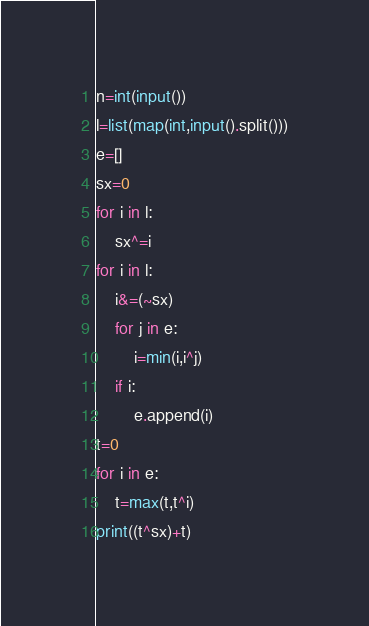Convert code to text. <code><loc_0><loc_0><loc_500><loc_500><_Python_>n=int(input())
l=list(map(int,input().split()))
e=[]
sx=0
for i in l:
    sx^=i
for i in l:
    i&=(~sx)
    for j in e:
        i=min(i,i^j)
    if i:
        e.append(i)
t=0
for i in e:
    t=max(t,t^i)
print((t^sx)+t)</code> 